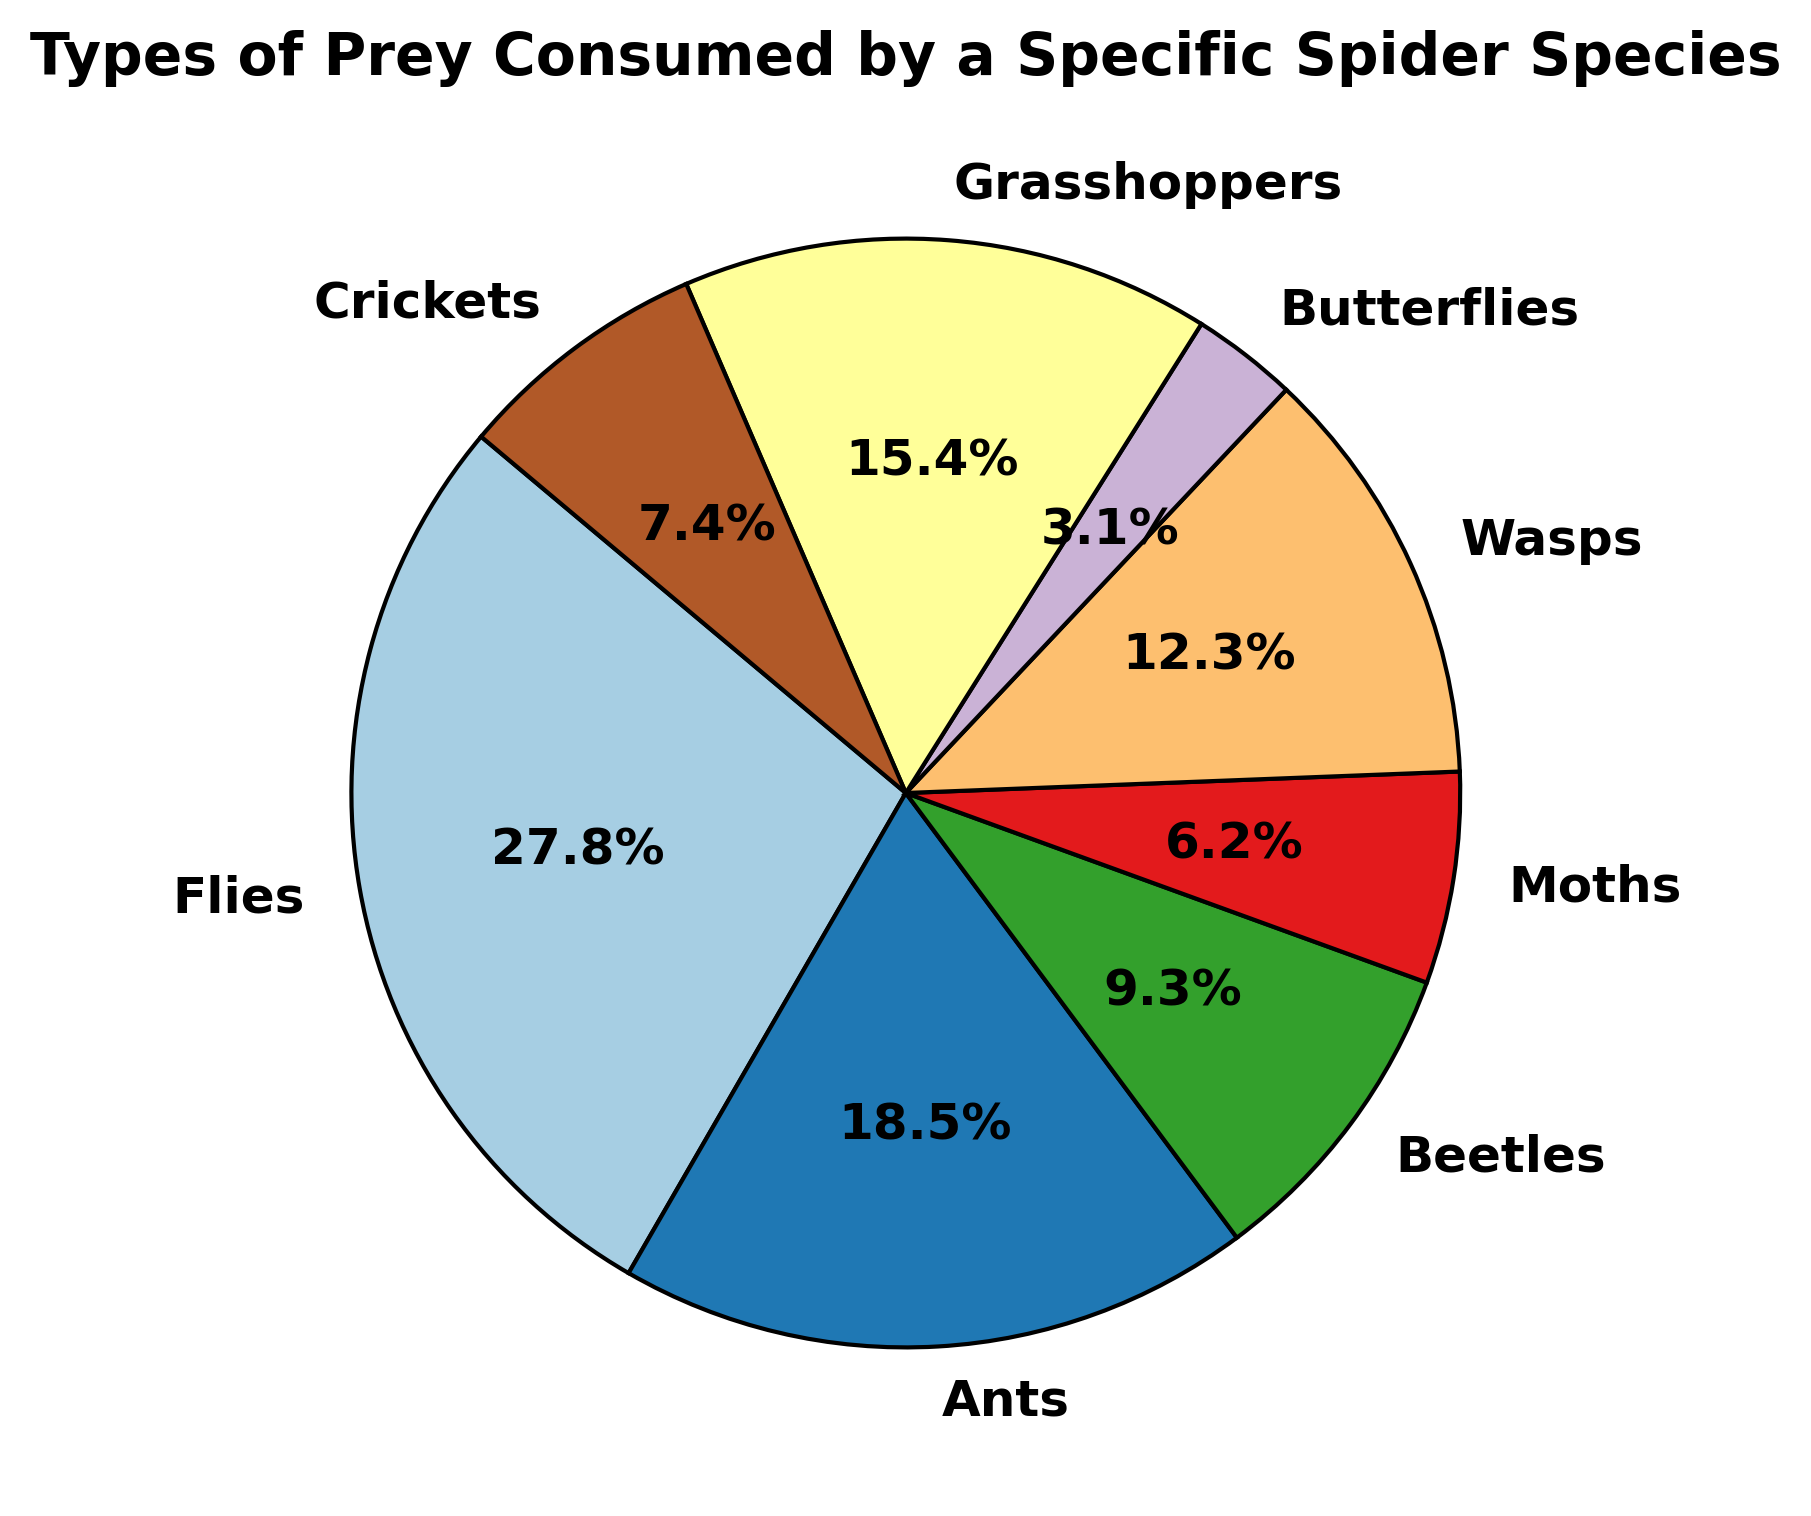Which prey type is consumed the most by the spider species? By observing the pie chart, we identify that the largest slice of the pie represents Flies. Thus, Flies are the most consumed prey type.
Answer: Flies What percentage of the spider's diet is composed of Ants and Beetles combined? The chart shows that Ants make up 30% and Beetles make up 15%. Adding these percentages together, 30% + 15% = 45%.
Answer: 45% Are Wasps consumed more frequently or less frequently than Grasshoppers by the spider species? By comparing the pie slices, Wasps are represented by a smaller slice than Grasshoppers. Hence, Wasps are consumed less frequently than Grasshoppers.
Answer: Less frequently What is the difference in the number of Crickets and Butterflies consumed by the spider species? Crickets are consumed 12 times while Butterflies are consumed 5 times. The difference is 12 - 5 = 7.
Answer: 7 What portion of the pie chart is represented by Moths, and how does it visually compare to the portion represented by Crickets? Moths represent 10% of the chart, while Crickets represent 12%. Visually, the slice representing Crickets is slightly larger than the slice representing Moths.
Answer: Crickets' slice is larger What is the total number of prey consumed by this spider species as shown in the pie chart? By summing all the prey counts, 45 (Flies) + 30 (Ants) + 15 (Beetles) + 10 (Moths) + 20 (Wasps) + 5 (Butterflies) + 25 (Grasshoppers) + 12 (Crickets) = 162.
Answer: 162 Which three prey types form the top 50% of the spider's diet? By analyzing the percentages in descending order: Flies (27.8%), Ants (18.5%), Grasshoppers (15.4%), the top three combine to 27.8% + 18.5% + 15.4% = 61.7%. Flies, Ants, and Grasshoppers together exceed 50%.
Answer: Flies, Ants, Grasshoppers What is the combined percentage of Flies, Wasps, and Grasshoppers in the spider's diet? Flies account for 27.8%, Wasps account for 12.3%, and Grasshoppers account for 15.4%. Adding these together, 27.8% + 12.3% + 15.4% = 55.5%.
Answer: 55.5% Which prey has the smallest portion in the diet, and what percentage of the diet does it represent? The smallest slice on the pie chart is for Butterflies, which is 3.1% of the diet.
Answer: Butterflies, 3.1% 